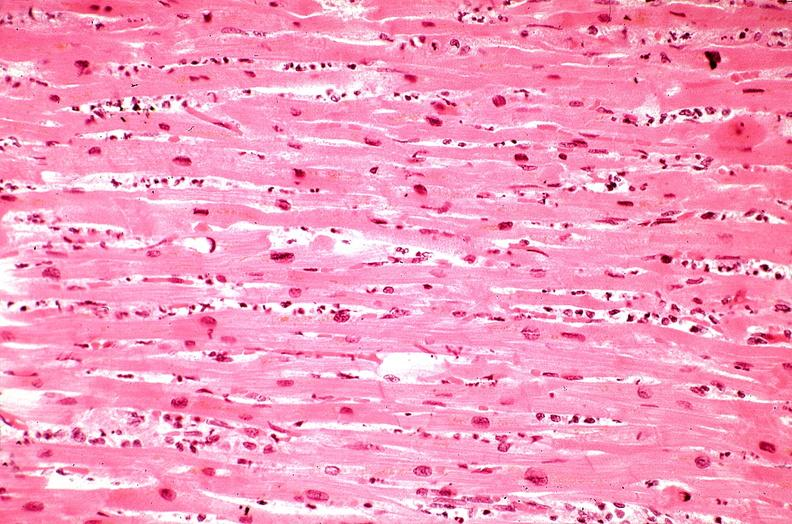does this image show heart, myocardial infarction, wavey fiber change, necrtosis, hemorrhage, and dissection?
Answer the question using a single word or phrase. Yes 